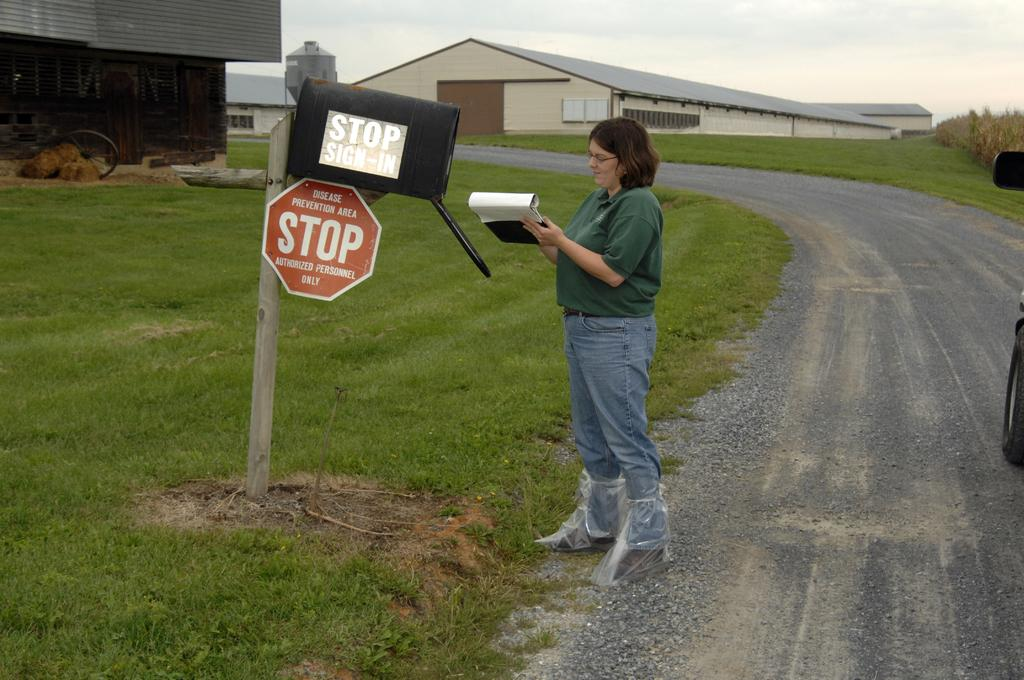<image>
Describe the image concisely. A woman is signing in on a clipboard, in front of a mailbox that is marked a disease prevention zone. 